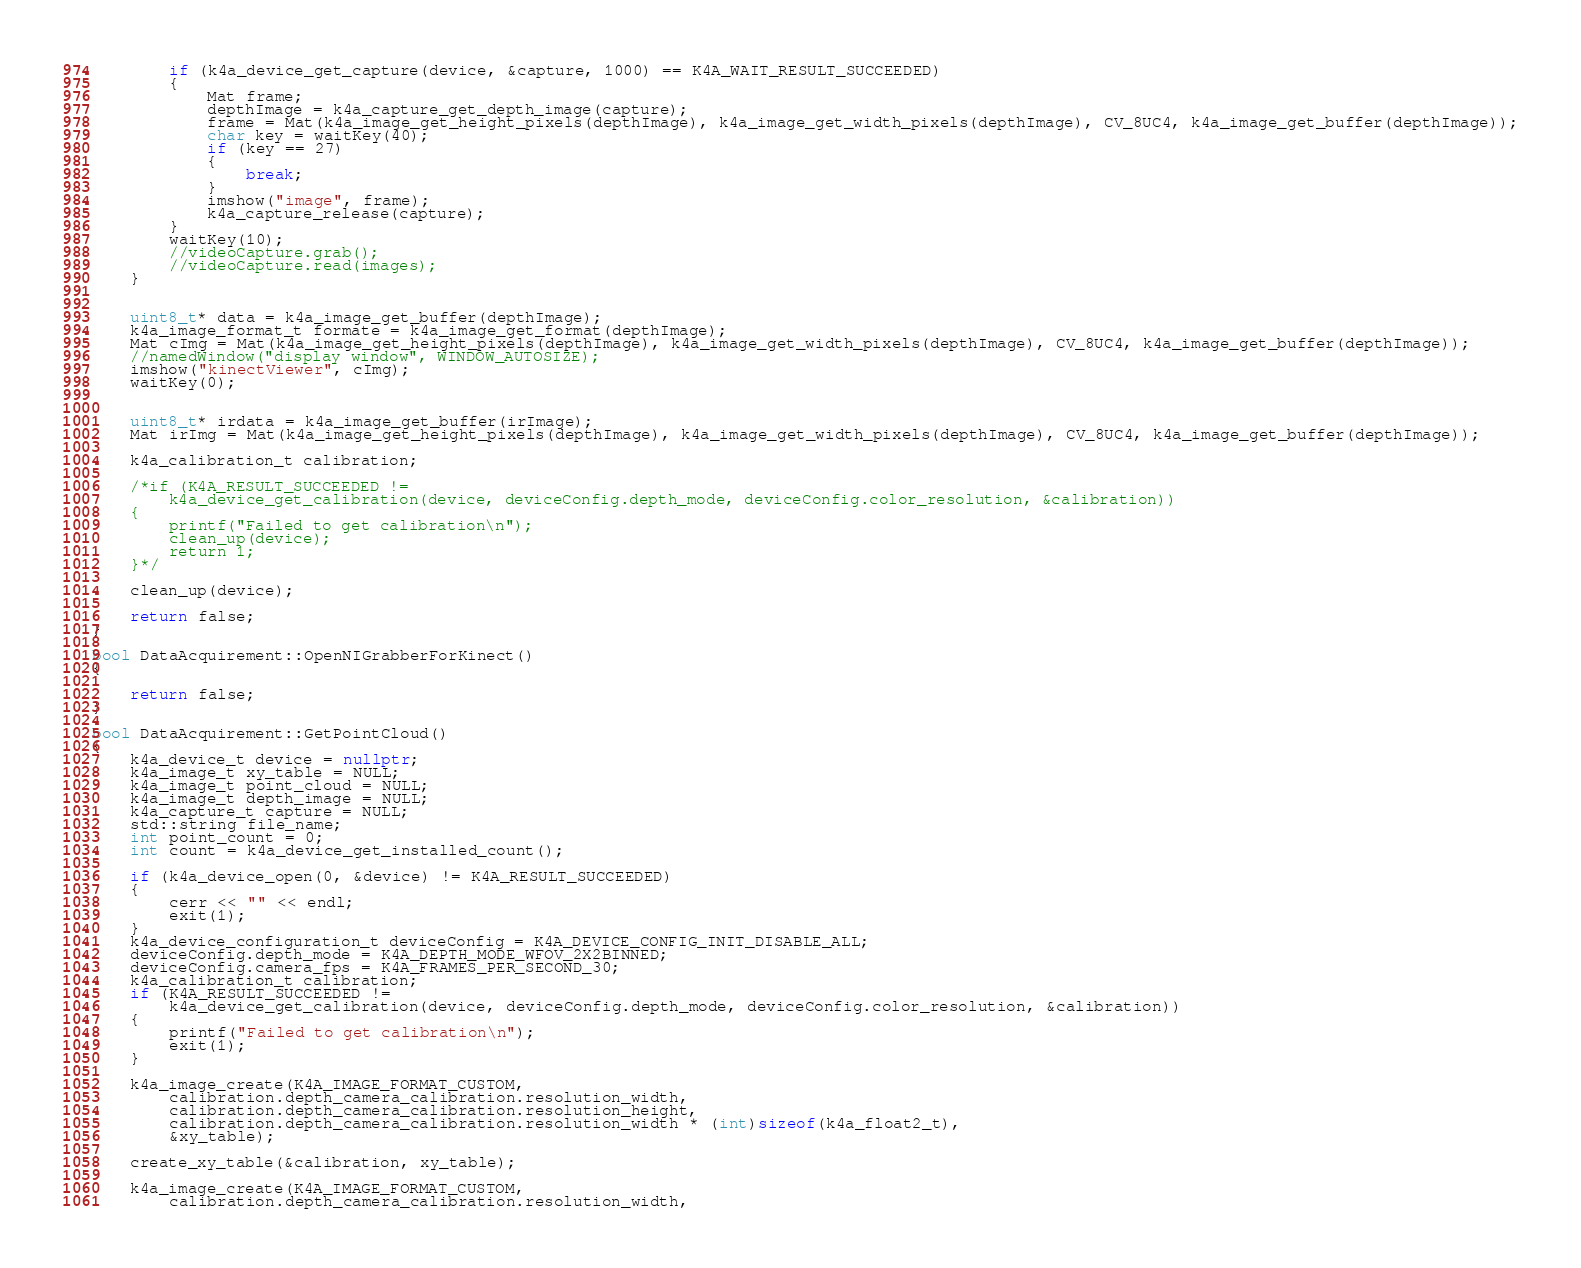<code> <loc_0><loc_0><loc_500><loc_500><_C++_>        if (k4a_device_get_capture(device, &capture, 1000) == K4A_WAIT_RESULT_SUCCEEDED)
        {
            Mat frame;
            depthImage = k4a_capture_get_depth_image(capture);
            frame = Mat(k4a_image_get_height_pixels(depthImage), k4a_image_get_width_pixels(depthImage), CV_8UC4, k4a_image_get_buffer(depthImage));
            char key = waitKey(40);
            if (key == 27)
            {
                break;
            }
            imshow("image", frame);
            k4a_capture_release(capture);
        }
        waitKey(10);
        //videoCapture.grab();
        //videoCapture.read(images);
    }


    uint8_t* data = k4a_image_get_buffer(depthImage);
    k4a_image_format_t formate = k4a_image_get_format(depthImage);
    Mat cImg = Mat(k4a_image_get_height_pixels(depthImage), k4a_image_get_width_pixels(depthImage), CV_8UC4, k4a_image_get_buffer(depthImage));
    //namedWindow("display window", WINDOW_AUTOSIZE);
    imshow("kinectViewer", cImg);
    waitKey(0);


    uint8_t* irdata = k4a_image_get_buffer(irImage);
    Mat irImg = Mat(k4a_image_get_height_pixels(depthImage), k4a_image_get_width_pixels(depthImage), CV_8UC4, k4a_image_get_buffer(depthImage));

	k4a_calibration_t calibration;

	/*if (K4A_RESULT_SUCCEEDED !=
		k4a_device_get_calibration(device, deviceConfig.depth_mode, deviceConfig.color_resolution, &calibration))
	{
		printf("Failed to get calibration\n");
		clean_up(device);
		return 1;
	}*/

    clean_up(device);
	
	return false;
}

bool DataAcquirement::OpenNIGrabberForKinect()
{

    return false;
}

bool DataAcquirement::GetPointCloud()
{
    k4a_device_t device = nullptr;
    k4a_image_t xy_table = NULL;
    k4a_image_t point_cloud = NULL;
    k4a_image_t depth_image = NULL;
    k4a_capture_t capture = NULL;
    std::string file_name;
    int point_count = 0;
    int count = k4a_device_get_installed_count();

    if (k4a_device_open(0, &device) != K4A_RESULT_SUCCEEDED)
    {
        cerr << "" << endl;
        exit(1);
    }
    k4a_device_configuration_t deviceConfig = K4A_DEVICE_CONFIG_INIT_DISABLE_ALL;
    deviceConfig.depth_mode = K4A_DEPTH_MODE_WFOV_2X2BINNED;
    deviceConfig.camera_fps = K4A_FRAMES_PER_SECOND_30;
    k4a_calibration_t calibration;
    if (K4A_RESULT_SUCCEEDED !=
        k4a_device_get_calibration(device, deviceConfig.depth_mode, deviceConfig.color_resolution, &calibration))
    {
        printf("Failed to get calibration\n");
        exit(1);
    }

    k4a_image_create(K4A_IMAGE_FORMAT_CUSTOM,
        calibration.depth_camera_calibration.resolution_width,
        calibration.depth_camera_calibration.resolution_height,
        calibration.depth_camera_calibration.resolution_width * (int)sizeof(k4a_float2_t),
        &xy_table);

    create_xy_table(&calibration, xy_table);

    k4a_image_create(K4A_IMAGE_FORMAT_CUSTOM,
        calibration.depth_camera_calibration.resolution_width,</code> 